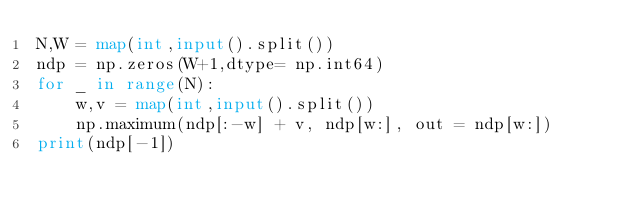Convert code to text. <code><loc_0><loc_0><loc_500><loc_500><_Python_>N,W = map(int,input().split())
ndp = np.zeros(W+1,dtype= np.int64)
for _ in range(N):
    w,v = map(int,input().split())
    np.maximum(ndp[:-w] + v, ndp[w:], out = ndp[w:])
print(ndp[-1])</code> 